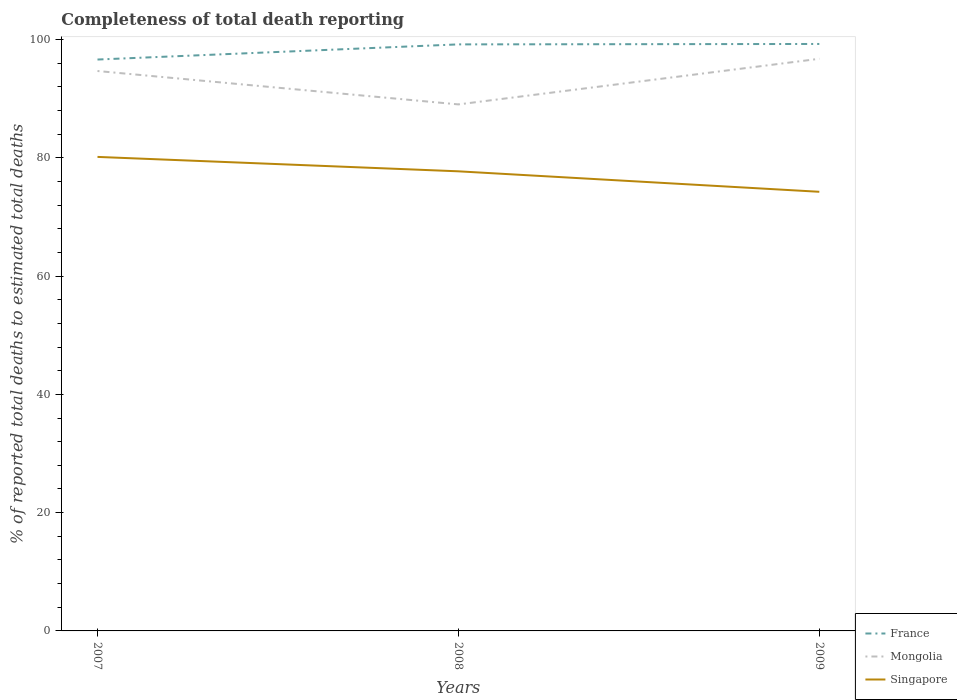Does the line corresponding to Singapore intersect with the line corresponding to France?
Provide a succinct answer. No. Is the number of lines equal to the number of legend labels?
Keep it short and to the point. Yes. Across all years, what is the maximum percentage of total deaths reported in Singapore?
Your answer should be compact. 74.26. What is the total percentage of total deaths reported in Mongolia in the graph?
Your answer should be compact. -2.07. What is the difference between the highest and the second highest percentage of total deaths reported in France?
Make the answer very short. 2.63. How many lines are there?
Make the answer very short. 3. How many years are there in the graph?
Offer a very short reply. 3. Does the graph contain any zero values?
Provide a succinct answer. No. How are the legend labels stacked?
Provide a succinct answer. Vertical. What is the title of the graph?
Offer a very short reply. Completeness of total death reporting. What is the label or title of the X-axis?
Keep it short and to the point. Years. What is the label or title of the Y-axis?
Your answer should be compact. % of reported total deaths to estimated total deaths. What is the % of reported total deaths to estimated total deaths in France in 2007?
Give a very brief answer. 96.62. What is the % of reported total deaths to estimated total deaths of Mongolia in 2007?
Keep it short and to the point. 94.68. What is the % of reported total deaths to estimated total deaths of Singapore in 2007?
Provide a succinct answer. 80.16. What is the % of reported total deaths to estimated total deaths in France in 2008?
Ensure brevity in your answer.  99.19. What is the % of reported total deaths to estimated total deaths in Mongolia in 2008?
Ensure brevity in your answer.  89.04. What is the % of reported total deaths to estimated total deaths of Singapore in 2008?
Your response must be concise. 77.72. What is the % of reported total deaths to estimated total deaths in France in 2009?
Ensure brevity in your answer.  99.26. What is the % of reported total deaths to estimated total deaths in Mongolia in 2009?
Provide a short and direct response. 96.75. What is the % of reported total deaths to estimated total deaths in Singapore in 2009?
Provide a short and direct response. 74.26. Across all years, what is the maximum % of reported total deaths to estimated total deaths in France?
Provide a succinct answer. 99.26. Across all years, what is the maximum % of reported total deaths to estimated total deaths in Mongolia?
Offer a very short reply. 96.75. Across all years, what is the maximum % of reported total deaths to estimated total deaths of Singapore?
Keep it short and to the point. 80.16. Across all years, what is the minimum % of reported total deaths to estimated total deaths in France?
Keep it short and to the point. 96.62. Across all years, what is the minimum % of reported total deaths to estimated total deaths of Mongolia?
Provide a short and direct response. 89.04. Across all years, what is the minimum % of reported total deaths to estimated total deaths of Singapore?
Provide a short and direct response. 74.26. What is the total % of reported total deaths to estimated total deaths in France in the graph?
Your answer should be very brief. 295.07. What is the total % of reported total deaths to estimated total deaths in Mongolia in the graph?
Your answer should be very brief. 280.47. What is the total % of reported total deaths to estimated total deaths in Singapore in the graph?
Provide a succinct answer. 232.14. What is the difference between the % of reported total deaths to estimated total deaths of France in 2007 and that in 2008?
Keep it short and to the point. -2.56. What is the difference between the % of reported total deaths to estimated total deaths of Mongolia in 2007 and that in 2008?
Ensure brevity in your answer.  5.65. What is the difference between the % of reported total deaths to estimated total deaths in Singapore in 2007 and that in 2008?
Offer a very short reply. 2.44. What is the difference between the % of reported total deaths to estimated total deaths of France in 2007 and that in 2009?
Offer a very short reply. -2.63. What is the difference between the % of reported total deaths to estimated total deaths of Mongolia in 2007 and that in 2009?
Give a very brief answer. -2.07. What is the difference between the % of reported total deaths to estimated total deaths in Singapore in 2007 and that in 2009?
Ensure brevity in your answer.  5.9. What is the difference between the % of reported total deaths to estimated total deaths of France in 2008 and that in 2009?
Keep it short and to the point. -0.07. What is the difference between the % of reported total deaths to estimated total deaths of Mongolia in 2008 and that in 2009?
Your response must be concise. -7.71. What is the difference between the % of reported total deaths to estimated total deaths in Singapore in 2008 and that in 2009?
Your answer should be compact. 3.46. What is the difference between the % of reported total deaths to estimated total deaths of France in 2007 and the % of reported total deaths to estimated total deaths of Mongolia in 2008?
Your answer should be very brief. 7.59. What is the difference between the % of reported total deaths to estimated total deaths in France in 2007 and the % of reported total deaths to estimated total deaths in Singapore in 2008?
Ensure brevity in your answer.  18.9. What is the difference between the % of reported total deaths to estimated total deaths of Mongolia in 2007 and the % of reported total deaths to estimated total deaths of Singapore in 2008?
Keep it short and to the point. 16.96. What is the difference between the % of reported total deaths to estimated total deaths of France in 2007 and the % of reported total deaths to estimated total deaths of Mongolia in 2009?
Your response must be concise. -0.13. What is the difference between the % of reported total deaths to estimated total deaths of France in 2007 and the % of reported total deaths to estimated total deaths of Singapore in 2009?
Keep it short and to the point. 22.37. What is the difference between the % of reported total deaths to estimated total deaths of Mongolia in 2007 and the % of reported total deaths to estimated total deaths of Singapore in 2009?
Offer a very short reply. 20.42. What is the difference between the % of reported total deaths to estimated total deaths in France in 2008 and the % of reported total deaths to estimated total deaths in Mongolia in 2009?
Provide a succinct answer. 2.44. What is the difference between the % of reported total deaths to estimated total deaths of France in 2008 and the % of reported total deaths to estimated total deaths of Singapore in 2009?
Your answer should be compact. 24.93. What is the difference between the % of reported total deaths to estimated total deaths in Mongolia in 2008 and the % of reported total deaths to estimated total deaths in Singapore in 2009?
Your answer should be very brief. 14.78. What is the average % of reported total deaths to estimated total deaths in France per year?
Give a very brief answer. 98.36. What is the average % of reported total deaths to estimated total deaths of Mongolia per year?
Give a very brief answer. 93.49. What is the average % of reported total deaths to estimated total deaths in Singapore per year?
Offer a very short reply. 77.38. In the year 2007, what is the difference between the % of reported total deaths to estimated total deaths of France and % of reported total deaths to estimated total deaths of Mongolia?
Provide a short and direct response. 1.94. In the year 2007, what is the difference between the % of reported total deaths to estimated total deaths of France and % of reported total deaths to estimated total deaths of Singapore?
Your answer should be compact. 16.47. In the year 2007, what is the difference between the % of reported total deaths to estimated total deaths in Mongolia and % of reported total deaths to estimated total deaths in Singapore?
Your answer should be compact. 14.53. In the year 2008, what is the difference between the % of reported total deaths to estimated total deaths of France and % of reported total deaths to estimated total deaths of Mongolia?
Your answer should be very brief. 10.15. In the year 2008, what is the difference between the % of reported total deaths to estimated total deaths in France and % of reported total deaths to estimated total deaths in Singapore?
Provide a short and direct response. 21.47. In the year 2008, what is the difference between the % of reported total deaths to estimated total deaths of Mongolia and % of reported total deaths to estimated total deaths of Singapore?
Keep it short and to the point. 11.32. In the year 2009, what is the difference between the % of reported total deaths to estimated total deaths of France and % of reported total deaths to estimated total deaths of Mongolia?
Your response must be concise. 2.51. In the year 2009, what is the difference between the % of reported total deaths to estimated total deaths in France and % of reported total deaths to estimated total deaths in Singapore?
Ensure brevity in your answer.  25. In the year 2009, what is the difference between the % of reported total deaths to estimated total deaths in Mongolia and % of reported total deaths to estimated total deaths in Singapore?
Your answer should be compact. 22.49. What is the ratio of the % of reported total deaths to estimated total deaths of France in 2007 to that in 2008?
Your answer should be compact. 0.97. What is the ratio of the % of reported total deaths to estimated total deaths in Mongolia in 2007 to that in 2008?
Your answer should be compact. 1.06. What is the ratio of the % of reported total deaths to estimated total deaths in Singapore in 2007 to that in 2008?
Your response must be concise. 1.03. What is the ratio of the % of reported total deaths to estimated total deaths in France in 2007 to that in 2009?
Offer a terse response. 0.97. What is the ratio of the % of reported total deaths to estimated total deaths of Mongolia in 2007 to that in 2009?
Your answer should be very brief. 0.98. What is the ratio of the % of reported total deaths to estimated total deaths of Singapore in 2007 to that in 2009?
Make the answer very short. 1.08. What is the ratio of the % of reported total deaths to estimated total deaths in France in 2008 to that in 2009?
Keep it short and to the point. 1. What is the ratio of the % of reported total deaths to estimated total deaths of Mongolia in 2008 to that in 2009?
Provide a short and direct response. 0.92. What is the ratio of the % of reported total deaths to estimated total deaths in Singapore in 2008 to that in 2009?
Your answer should be compact. 1.05. What is the difference between the highest and the second highest % of reported total deaths to estimated total deaths in France?
Offer a very short reply. 0.07. What is the difference between the highest and the second highest % of reported total deaths to estimated total deaths in Mongolia?
Your answer should be very brief. 2.07. What is the difference between the highest and the second highest % of reported total deaths to estimated total deaths of Singapore?
Keep it short and to the point. 2.44. What is the difference between the highest and the lowest % of reported total deaths to estimated total deaths in France?
Give a very brief answer. 2.63. What is the difference between the highest and the lowest % of reported total deaths to estimated total deaths in Mongolia?
Offer a terse response. 7.71. What is the difference between the highest and the lowest % of reported total deaths to estimated total deaths of Singapore?
Make the answer very short. 5.9. 